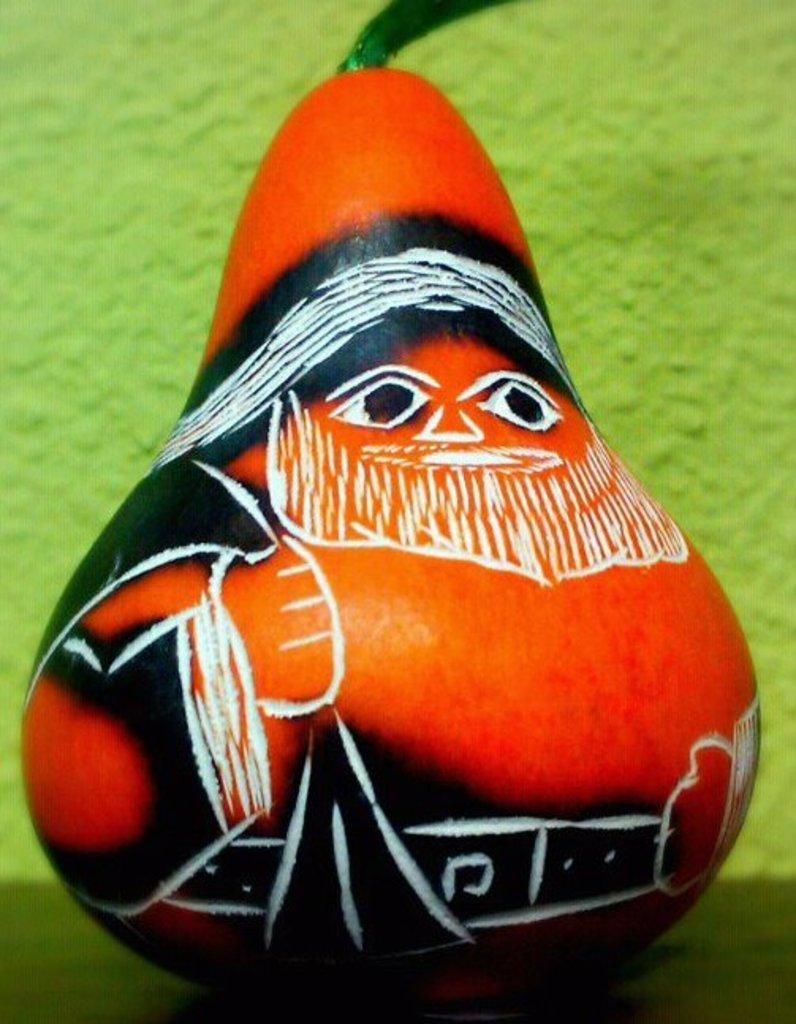Please provide a concise description of this image. There is a painting on a long orange pumpkin. There is a green background. 